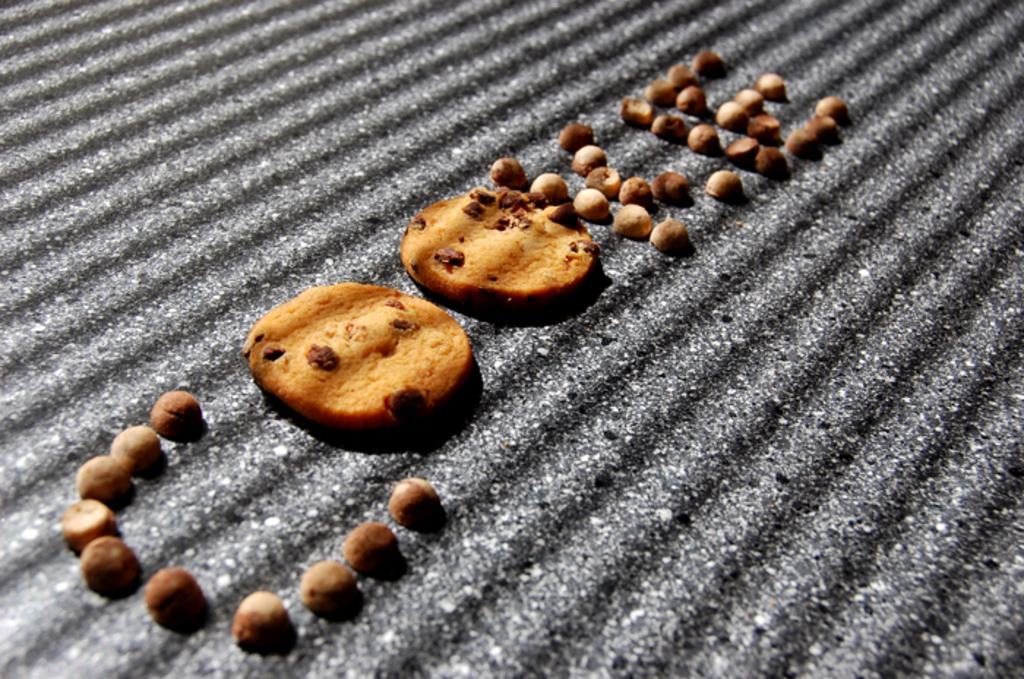What type of food can be seen in the image? There are cookies in the image. What is the cookies placed on? The cookies are placed on a black color sheet. What type of pain is the person experiencing in the image? There is no person present in the image, and therefore no indication of any pain being experienced. 